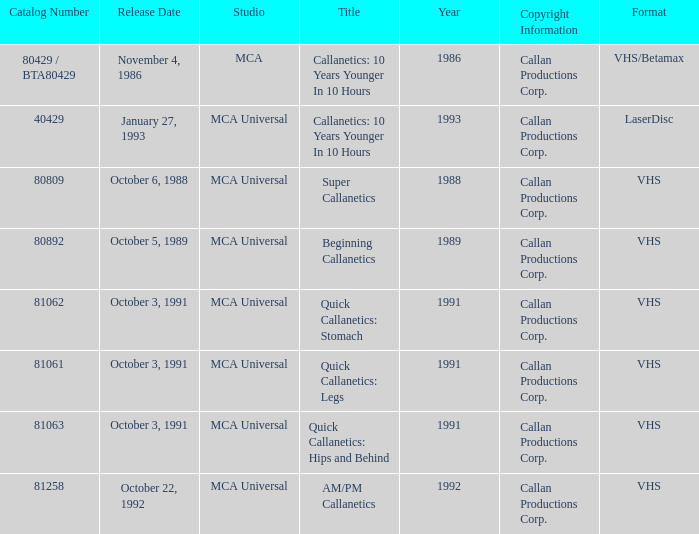Name the catalog number for am/pm callanetics 81258.0. 